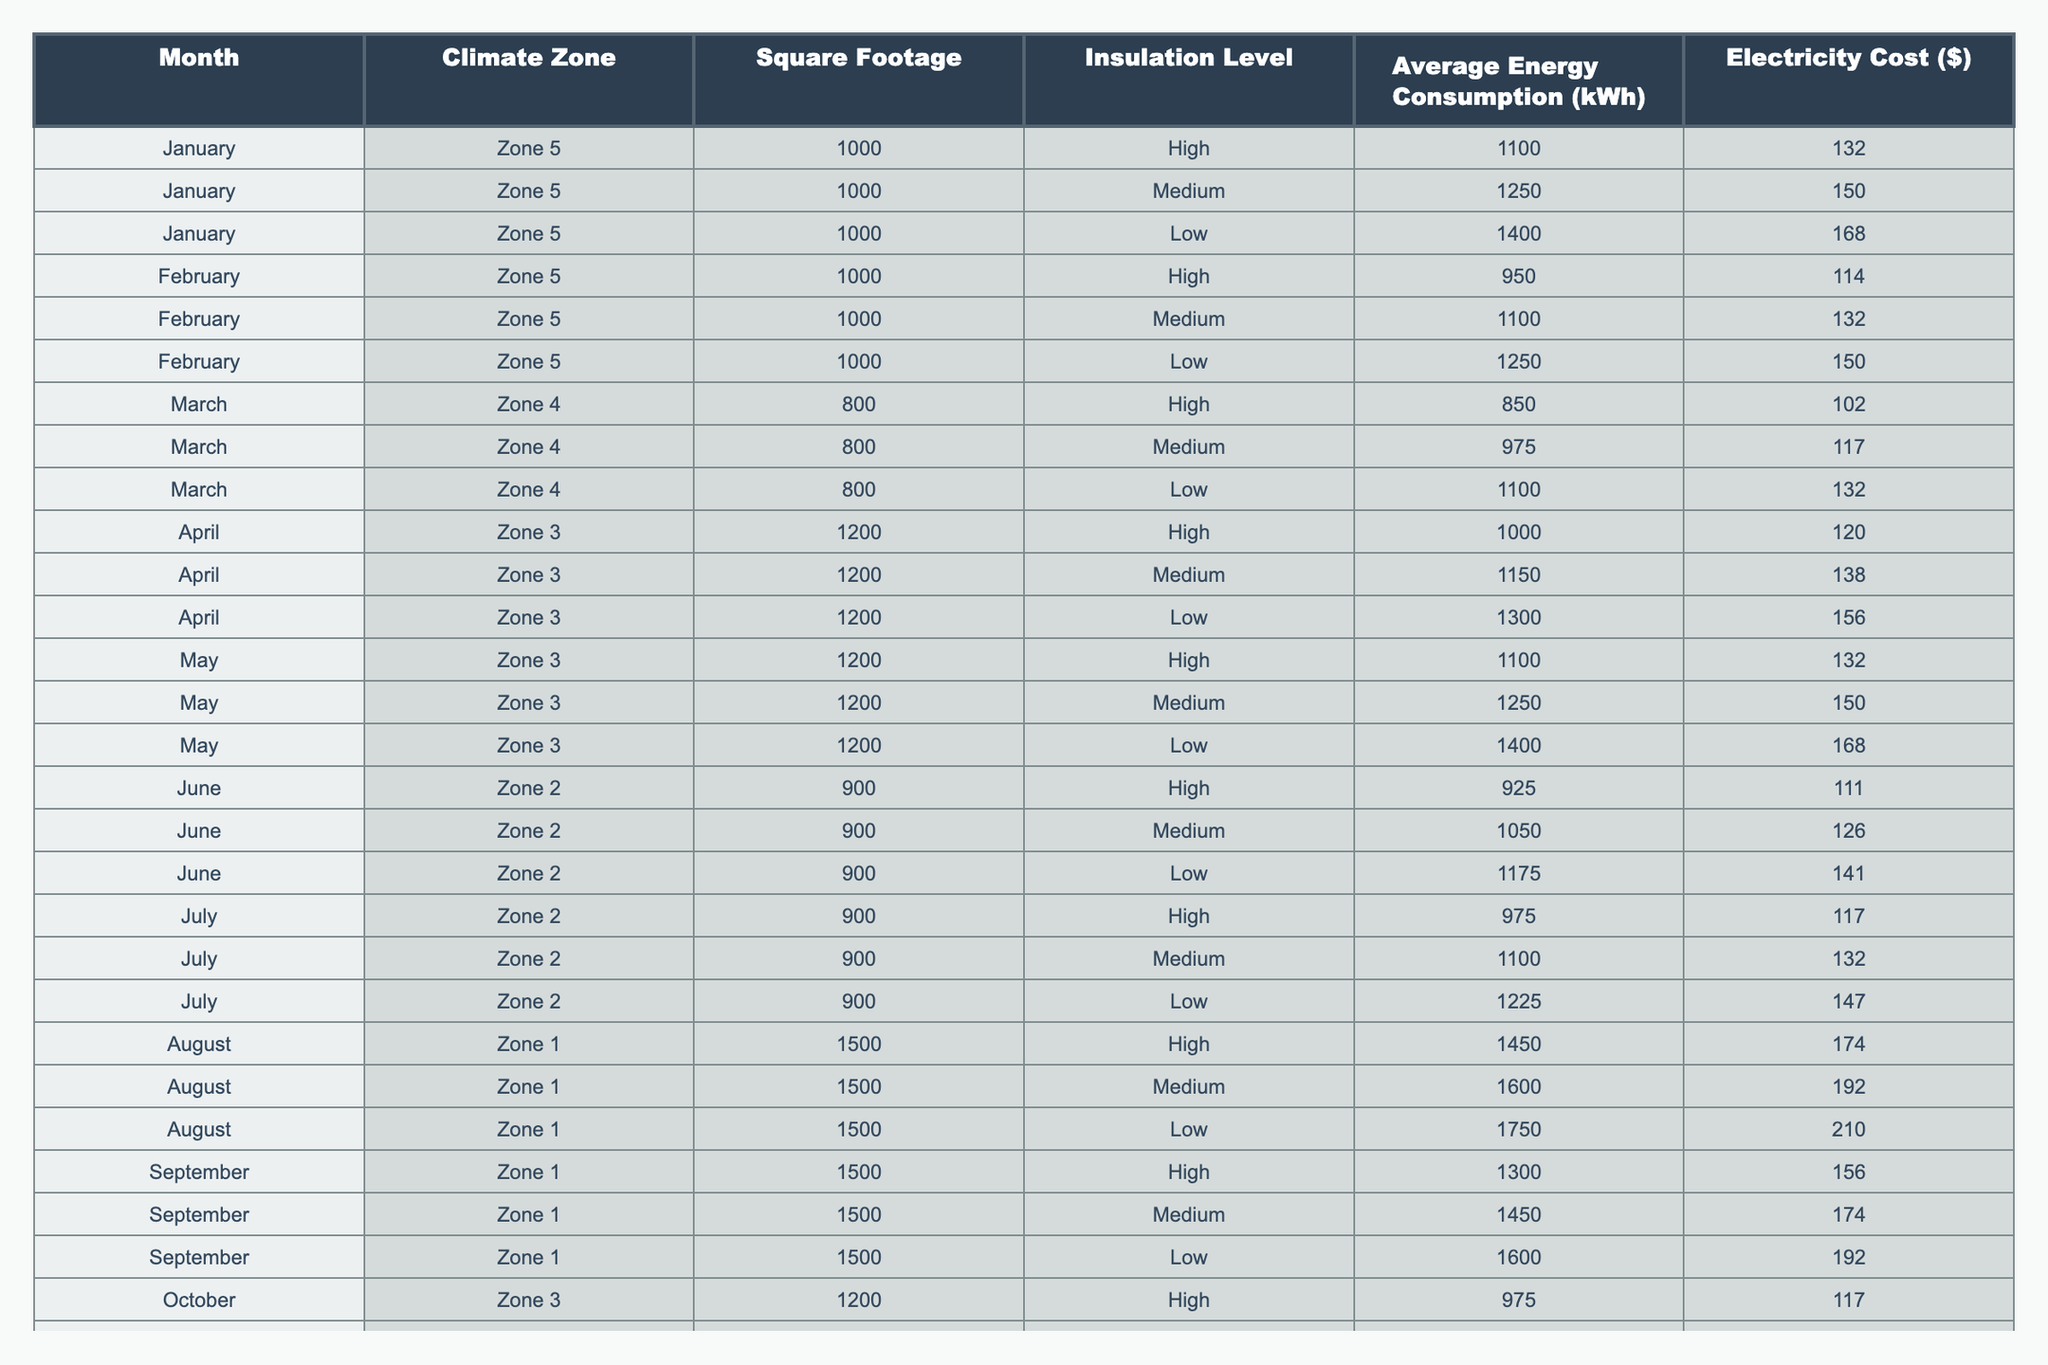What is the average energy consumption in January for a climate zone 5 garage with high insulation? In January, for Zone 5 with high insulation, the energy consumption is 1100 kWh. There is only one entry for this case, so the average is simply 1100 kWh.
Answer: 1100 kWh Which month has the highest average electricity cost in Zone 1? In Zone 1, the highest electricity cost is found in August, where the average cost is $210 for low insulation. Other months (like September) have lower costs.
Answer: August What is the total energy consumption for March in Zone 4? In March for Zone 4, the energy consumptions are 850 kWh (high insulation), 975 kWh (medium), and 1100 kWh (low). Adding these gives: 850 + 975 + 1100 = 2925 kWh.
Answer: 2925 kWh Is the average energy consumption higher in December than in February for Zone 5? In Zone 5, December's average consumption is (1175 + 1325 + 1475) / 3 = 1325 kWh, and February's is (950 + 1100 + 1250) / 3 = 1100 kWh. Since 1325 > 1100, the statement is true.
Answer: Yes What is the difference in average electricity cost between high and low insulation in June for Zone 2? In June for Zone 2, high insulation costs $111, while low insulation costs $141. The difference is $141 - $111 = $30.
Answer: $30 What is the minimum energy consumption recorded in January among the different insulation levels in Zone 5? The energy consumptions in January for Zone 5 are 1100 kWh (high), 1250 kWh (medium), and 1400 kWh (low). The minimum is clearly 1100 kWh for high insulation.
Answer: 1100 kWh How does the average energy consumption for the highest insulation level differ from the lowest across all months in Zone 3? In Zone 3, the values for high insulation across the months (April: 1000, May: 1100, October: 975) average to (1000 + 1100 + 975) / 3 = 1025 kWh for high insulation, and for low insulation (April: 1300, May: 1400, October: 1225), it averages (1300 + 1400 + 1225) / 3 = 1308.33 kWh. The difference is 1308.33 - 1025 = 283.33 kWh.
Answer: 283.33 kWh Which month shows the least variation in average energy consumption between insulation levels in Zone 2? In Zone 2, for June, the average consumption is (925 for high, 1050 for medium, and 1175 for low). The variations are: 125 (high to medium) and 125 (medium to low). In July, the variations are 125 (high to medium) and 125 (medium to low) too. Both months show similar variations, but checking their respective average values confirms less variability in June overall.
Answer: June What is the highest recorded energy consumption in Zone 1 for a climate-controlled garage? In Zone 1, the maximum consumption occurs in August for low insulation at 1750 kWh. Other months report lower values.
Answer: 1750 kWh 